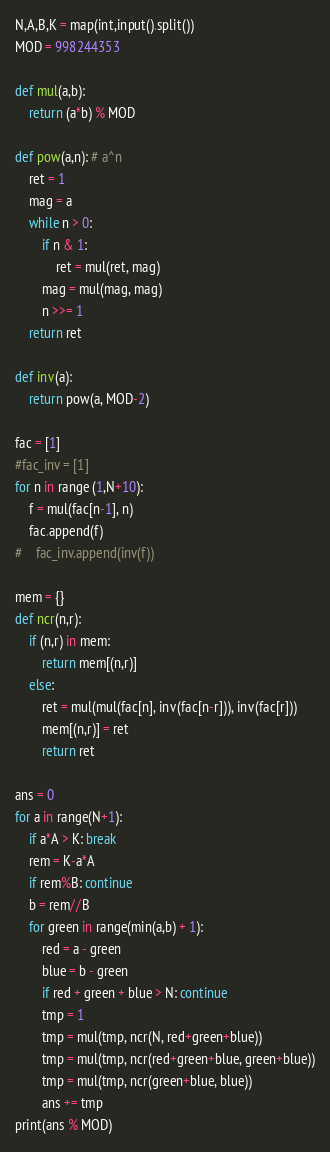<code> <loc_0><loc_0><loc_500><loc_500><_Python_>N,A,B,K = map(int,input().split())
MOD = 998244353

def mul(a,b):
    return (a*b) % MOD

def pow(a,n): # a^n
    ret = 1
    mag = a
    while n > 0:
        if n & 1:
            ret = mul(ret, mag)
        mag = mul(mag, mag)
        n >>= 1
    return ret

def inv(a):
    return pow(a, MOD-2)

fac = [1]
#fac_inv = [1]
for n in range (1,N+10):
    f = mul(fac[n-1], n)
    fac.append(f)
#    fac_inv.append(inv(f))

mem = {}
def ncr(n,r):
    if (n,r) in mem:
        return mem[(n,r)]
    else:
        ret = mul(mul(fac[n], inv(fac[n-r])), inv(fac[r]))
        mem[(n,r)] = ret
        return ret

ans = 0
for a in range(N+1):
    if a*A > K: break
    rem = K-a*A
    if rem%B: continue
    b = rem//B
    for green in range(min(a,b) + 1):
        red = a - green
        blue = b - green
        if red + green + blue > N: continue
        tmp = 1
        tmp = mul(tmp, ncr(N, red+green+blue))
        tmp = mul(tmp, ncr(red+green+blue, green+blue))
        tmp = mul(tmp, ncr(green+blue, blue))
        ans += tmp
print(ans % MOD)
</code> 